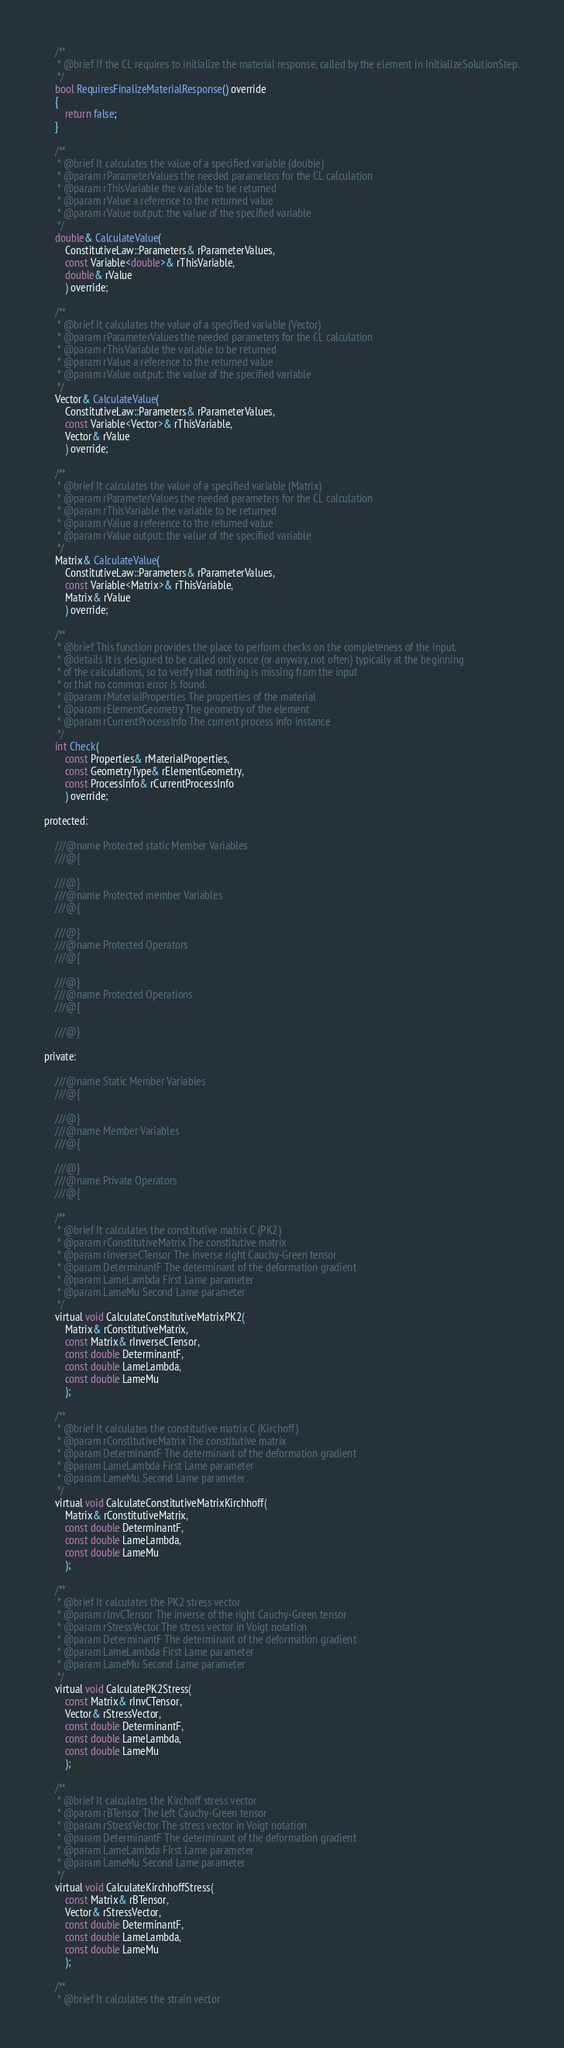<code> <loc_0><loc_0><loc_500><loc_500><_C_>
    /**
     * @brief If the CL requires to initialize the material response, called by the element in InitializeSolutionStep.
     */
    bool RequiresFinalizeMaterialResponse() override
    {
        return false;
    }

    /**
     * @brief It calculates the value of a specified variable (double)
     * @param rParameterValues the needed parameters for the CL calculation
     * @param rThisVariable the variable to be returned
     * @param rValue a reference to the returned value
     * @param rValue output: the value of the specified variable
     */
    double& CalculateValue(
        ConstitutiveLaw::Parameters& rParameterValues,
        const Variable<double>& rThisVariable,
        double& rValue
        ) override;

    /**
     * @brief It calculates the value of a specified variable (Vector)
     * @param rParameterValues the needed parameters for the CL calculation
     * @param rThisVariable the variable to be returned
     * @param rValue a reference to the returned value
     * @param rValue output: the value of the specified variable
     */
    Vector& CalculateValue(
        ConstitutiveLaw::Parameters& rParameterValues,
        const Variable<Vector>& rThisVariable,
        Vector& rValue
        ) override;

    /**
     * @brief It calculates the value of a specified variable (Matrix)
     * @param rParameterValues the needed parameters for the CL calculation
     * @param rThisVariable the variable to be returned
     * @param rValue a reference to the returned value
     * @param rValue output: the value of the specified variable
     */
    Matrix& CalculateValue(
        ConstitutiveLaw::Parameters& rParameterValues,
        const Variable<Matrix>& rThisVariable,
        Matrix& rValue
        ) override;

    /**
     * @brief This function provides the place to perform checks on the completeness of the input.
     * @details It is designed to be called only once (or anyway, not often) typically at the beginning
     * of the calculations, so to verify that nothing is missing from the input
     * or that no common error is found.
     * @param rMaterialProperties The properties of the material
     * @param rElementGeometry The geometry of the element
     * @param rCurrentProcessInfo The current process info instance
     */
    int Check(
        const Properties& rMaterialProperties,
        const GeometryType& rElementGeometry,
        const ProcessInfo& rCurrentProcessInfo
        ) override;

protected:

    ///@name Protected static Member Variables
    ///@{

    ///@}
    ///@name Protected member Variables
    ///@{

    ///@}
    ///@name Protected Operators
    ///@{

    ///@}
    ///@name Protected Operations
    ///@{

    ///@}

private:

    ///@name Static Member Variables
    ///@{

    ///@}
    ///@name Member Variables
    ///@{

    ///@}
    ///@name Private Operators
    ///@{

    /**
     * @brief It calculates the constitutive matrix C (PK2)
     * @param rConstitutiveMatrix The constitutive matrix
     * @param rInverseCTensor The inverse right Cauchy-Green tensor
     * @param DeterminantF The determinant of the deformation gradient
     * @param LameLambda First Lame parameter
     * @param LameMu Second Lame parameter
     */
    virtual void CalculateConstitutiveMatrixPK2(
        Matrix& rConstitutiveMatrix,
        const Matrix& rInverseCTensor,
        const double DeterminantF,
        const double LameLambda,
        const double LameMu
        );

    /**
     * @brief It calculates the constitutive matrix C (Kirchoff)
     * @param rConstitutiveMatrix The constitutive matrix
     * @param DeterminantF The determinant of the deformation gradient
     * @param LameLambda First Lame parameter
     * @param LameMu Second Lame parameter
     */
    virtual void CalculateConstitutiveMatrixKirchhoff(
        Matrix& rConstitutiveMatrix,
        const double DeterminantF,
        const double LameLambda,
        const double LameMu
        );

    /**
     * @brief It calculates the PK2 stress vector
     * @param rInvCTensor The inverse of the right Cauchy-Green tensor
     * @param rStressVector The stress vector in Voigt notation
     * @param DeterminantF The determinant of the deformation gradient
     * @param LameLambda First Lame parameter
     * @param LameMu Second Lame parameter
     */
    virtual void CalculatePK2Stress(
        const Matrix& rInvCTensor,
        Vector& rStressVector,
        const double DeterminantF,
        const double LameLambda,
        const double LameMu
        );

    /**
     * @brief It calculates the Kirchoff stress vector
     * @param rBTensor The left Cauchy-Green tensor
     * @param rStressVector The stress vector in Voigt notation
     * @param DeterminantF The determinant of the deformation gradient
     * @param LameLambda First Lame parameter
     * @param LameMu Second Lame parameter
     */
    virtual void CalculateKirchhoffStress(
        const Matrix& rBTensor,
        Vector& rStressVector,
        const double DeterminantF,
        const double LameLambda,
        const double LameMu
        );

    /**
     * @brief It calculates the strain vector</code> 